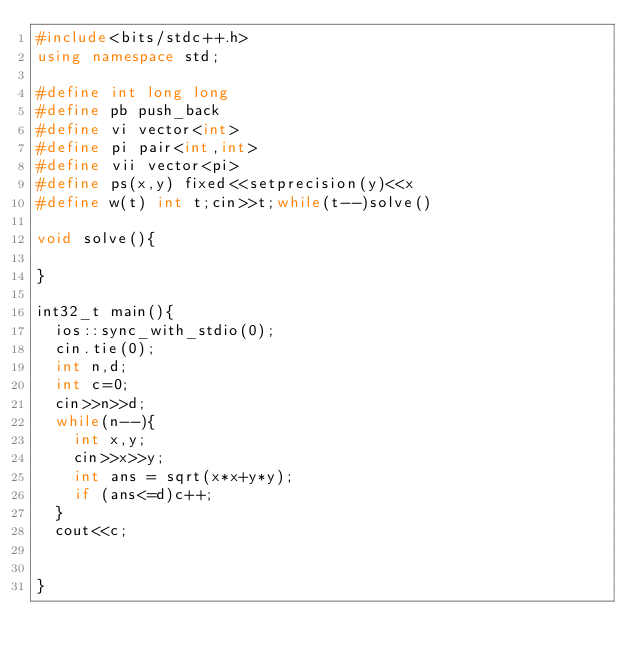<code> <loc_0><loc_0><loc_500><loc_500><_C++_>#include<bits/stdc++.h>
using namespace std;

#define int long long
#define pb push_back
#define vi vector<int>
#define pi pair<int,int>
#define vii vector<pi>
#define ps(x,y) fixed<<setprecision(y)<<x
#define w(t) int t;cin>>t;while(t--)solve()

void solve(){
	
}

int32_t main(){
	ios::sync_with_stdio(0);
	cin.tie(0);
	int n,d;
	int c=0;
	cin>>n>>d;
	while(n--){
		int x,y;
		cin>>x>>y;
		int ans = sqrt(x*x+y*y);
		if (ans<=d)c++;
	}
	cout<<c;


}
</code> 